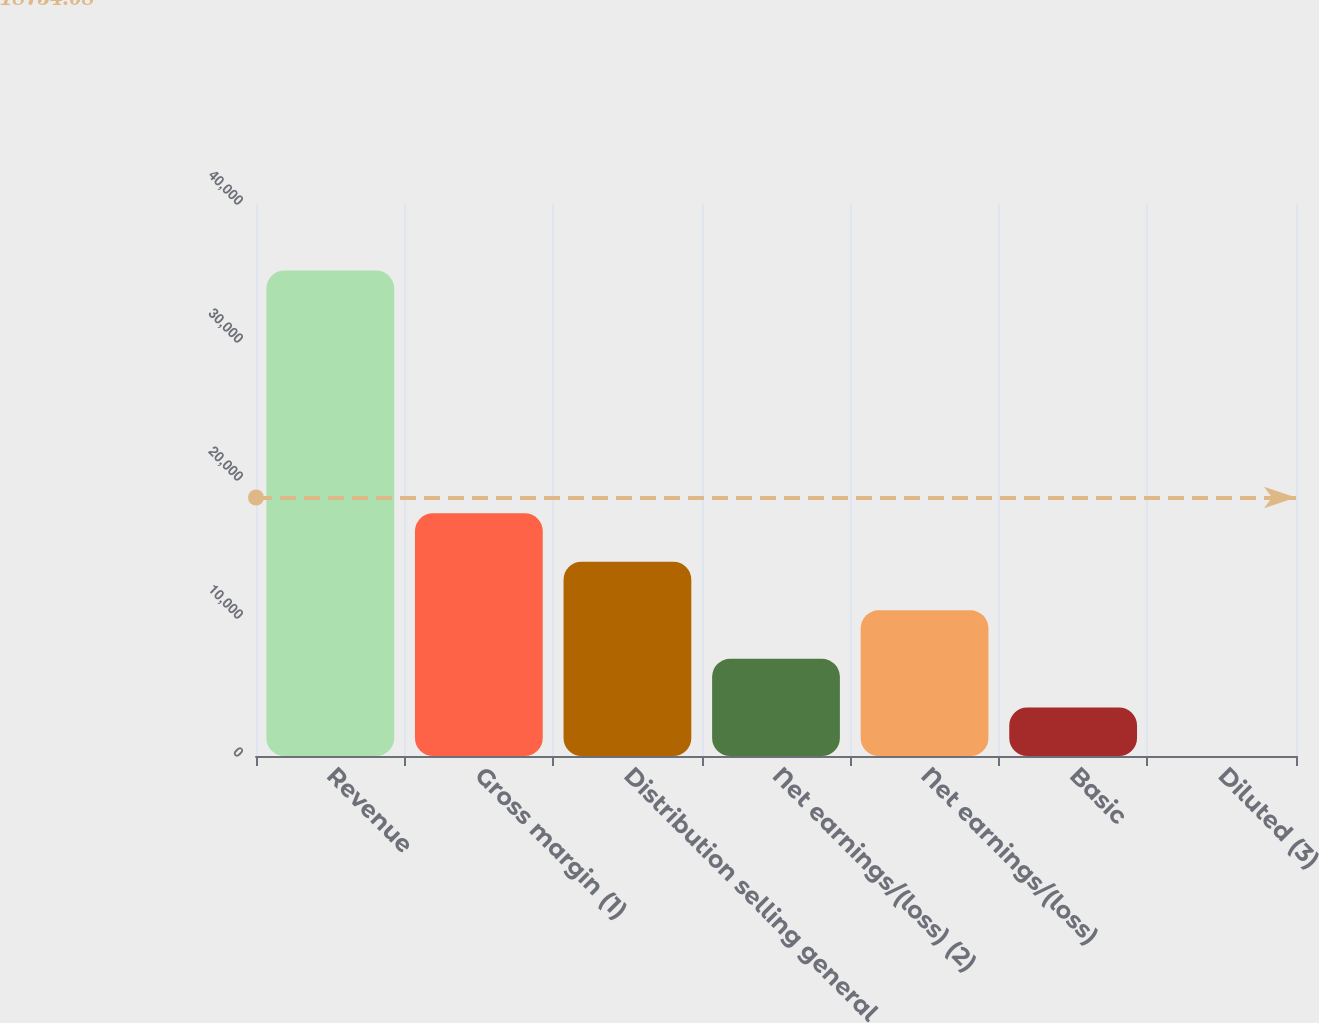<chart> <loc_0><loc_0><loc_500><loc_500><bar_chart><fcel>Revenue<fcel>Gross margin (1)<fcel>Distribution selling general<fcel>Net earnings/(loss) (2)<fcel>Net earnings/(loss)<fcel>Basic<fcel>Diluted (3)<nl><fcel>35186<fcel>17594.7<fcel>14076.4<fcel>7039.87<fcel>10558.1<fcel>3521.6<fcel>3.33<nl></chart> 